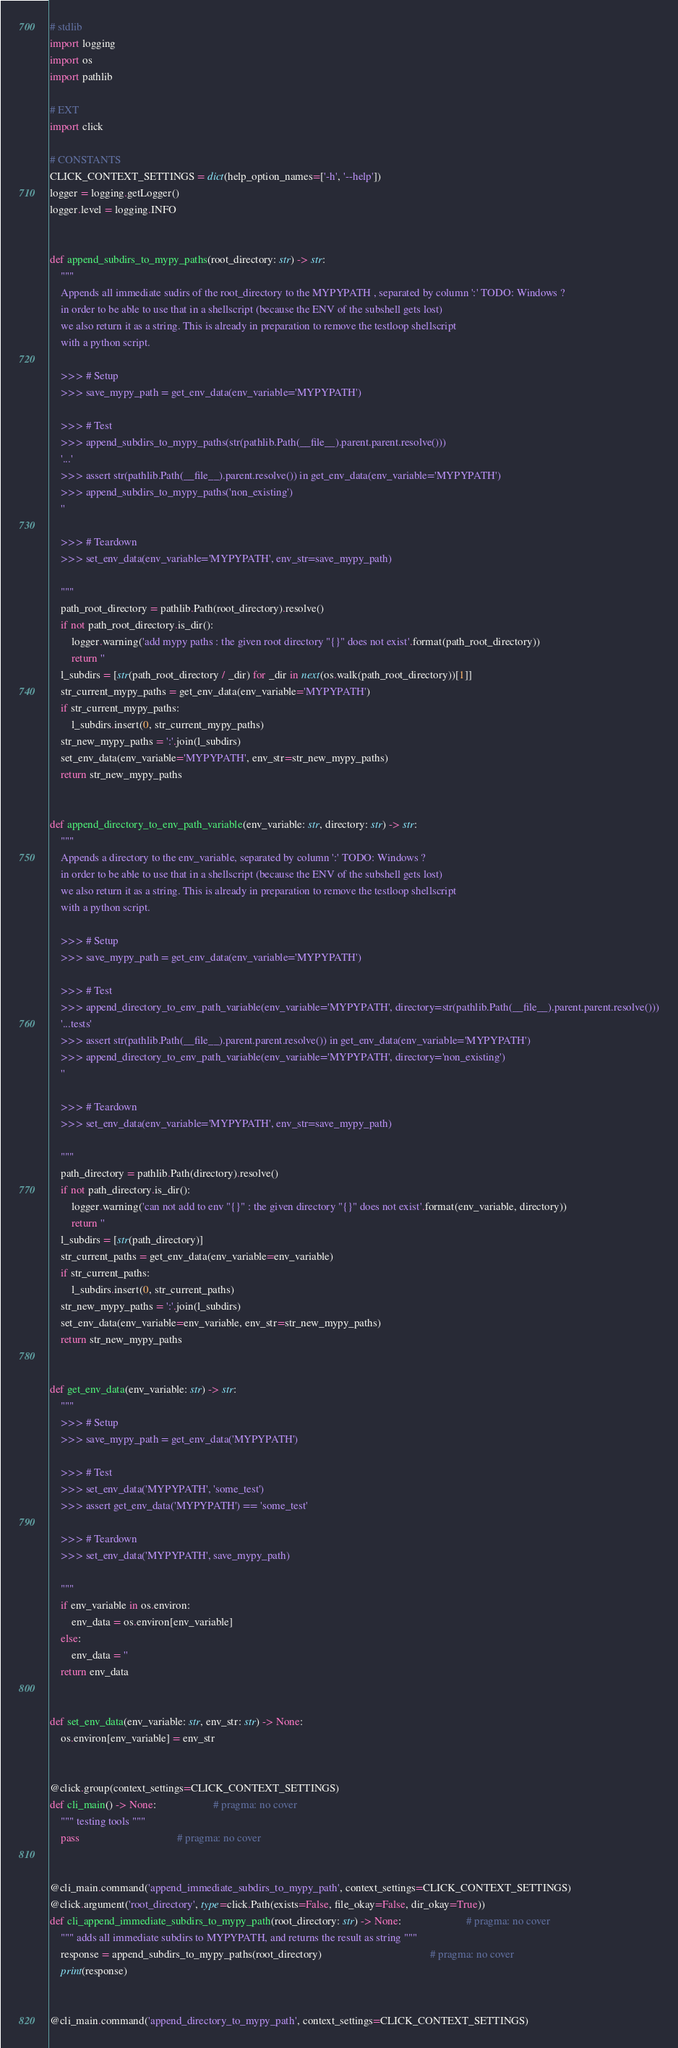<code> <loc_0><loc_0><loc_500><loc_500><_Python_># stdlib
import logging
import os
import pathlib

# EXT
import click

# CONSTANTS
CLICK_CONTEXT_SETTINGS = dict(help_option_names=['-h', '--help'])
logger = logging.getLogger()
logger.level = logging.INFO


def append_subdirs_to_mypy_paths(root_directory: str) -> str:
    """
    Appends all immediate sudirs of the root_directory to the MYPYPATH , separated by column ':' TODO: Windows ?
    in order to be able to use that in a shellscript (because the ENV of the subshell gets lost)
    we also return it as a string. This is already in preparation to remove the testloop shellscript
    with a python script.

    >>> # Setup
    >>> save_mypy_path = get_env_data(env_variable='MYPYPATH')

    >>> # Test
    >>> append_subdirs_to_mypy_paths(str(pathlib.Path(__file__).parent.parent.resolve()))
    '...'
    >>> assert str(pathlib.Path(__file__).parent.resolve()) in get_env_data(env_variable='MYPYPATH')
    >>> append_subdirs_to_mypy_paths('non_existing')
    ''

    >>> # Teardown
    >>> set_env_data(env_variable='MYPYPATH', env_str=save_mypy_path)

    """
    path_root_directory = pathlib.Path(root_directory).resolve()
    if not path_root_directory.is_dir():
        logger.warning('add mypy paths : the given root directory "{}" does not exist'.format(path_root_directory))
        return ''
    l_subdirs = [str(path_root_directory / _dir) for _dir in next(os.walk(path_root_directory))[1]]
    str_current_mypy_paths = get_env_data(env_variable='MYPYPATH')
    if str_current_mypy_paths:
        l_subdirs.insert(0, str_current_mypy_paths)
    str_new_mypy_paths = ':'.join(l_subdirs)
    set_env_data(env_variable='MYPYPATH', env_str=str_new_mypy_paths)
    return str_new_mypy_paths


def append_directory_to_env_path_variable(env_variable: str, directory: str) -> str:
    """
    Appends a directory to the env_variable, separated by column ':' TODO: Windows ?
    in order to be able to use that in a shellscript (because the ENV of the subshell gets lost)
    we also return it as a string. This is already in preparation to remove the testloop shellscript
    with a python script.

    >>> # Setup
    >>> save_mypy_path = get_env_data(env_variable='MYPYPATH')

    >>> # Test
    >>> append_directory_to_env_path_variable(env_variable='MYPYPATH', directory=str(pathlib.Path(__file__).parent.parent.resolve()))
    '...tests'
    >>> assert str(pathlib.Path(__file__).parent.parent.resolve()) in get_env_data(env_variable='MYPYPATH')
    >>> append_directory_to_env_path_variable(env_variable='MYPYPATH', directory='non_existing')
    ''

    >>> # Teardown
    >>> set_env_data(env_variable='MYPYPATH', env_str=save_mypy_path)

    """
    path_directory = pathlib.Path(directory).resolve()
    if not path_directory.is_dir():
        logger.warning('can not add to env "{}" : the given directory "{}" does not exist'.format(env_variable, directory))
        return ''
    l_subdirs = [str(path_directory)]
    str_current_paths = get_env_data(env_variable=env_variable)
    if str_current_paths:
        l_subdirs.insert(0, str_current_paths)
    str_new_mypy_paths = ':'.join(l_subdirs)
    set_env_data(env_variable=env_variable, env_str=str_new_mypy_paths)
    return str_new_mypy_paths


def get_env_data(env_variable: str) -> str:
    """
    >>> # Setup
    >>> save_mypy_path = get_env_data('MYPYPATH')

    >>> # Test
    >>> set_env_data('MYPYPATH', 'some_test')
    >>> assert get_env_data('MYPYPATH') == 'some_test'

    >>> # Teardown
    >>> set_env_data('MYPYPATH', save_mypy_path)

    """
    if env_variable in os.environ:
        env_data = os.environ[env_variable]
    else:
        env_data = ''
    return env_data


def set_env_data(env_variable: str, env_str: str) -> None:
    os.environ[env_variable] = env_str


@click.group(context_settings=CLICK_CONTEXT_SETTINGS)
def cli_main() -> None:                     # pragma: no cover
    """ testing tools """
    pass                                    # pragma: no cover


@cli_main.command('append_immediate_subdirs_to_mypy_path', context_settings=CLICK_CONTEXT_SETTINGS)
@click.argument('root_directory', type=click.Path(exists=False, file_okay=False, dir_okay=True))
def cli_append_immediate_subdirs_to_mypy_path(root_directory: str) -> None:                        # pragma: no cover
    """ adds all immediate subdirs to MYPYPATH, and returns the result as string """
    response = append_subdirs_to_mypy_paths(root_directory)                                        # pragma: no cover
    print(response)


@cli_main.command('append_directory_to_mypy_path', context_settings=CLICK_CONTEXT_SETTINGS)</code> 